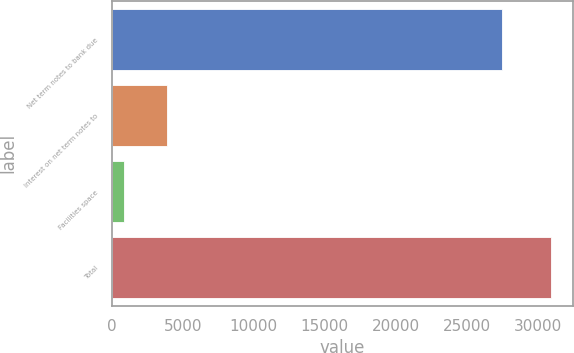Convert chart to OTSL. <chart><loc_0><loc_0><loc_500><loc_500><bar_chart><fcel>Net term notes to bank due<fcel>Interest on net term notes to<fcel>Facilities space<fcel>Total<nl><fcel>27512<fcel>3859.7<fcel>852<fcel>30929<nl></chart> 